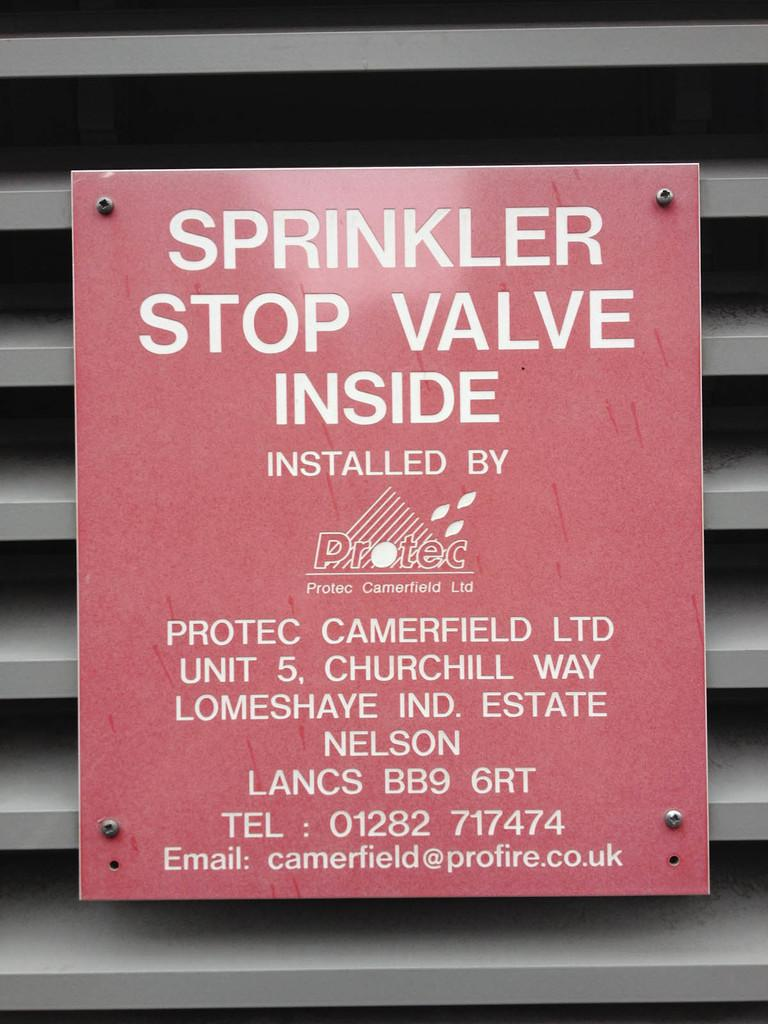Provide a one-sentence caption for the provided image. a poster in red titled 'sprinkler, stop valve inside'/. 